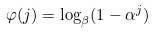Convert formula to latex. <formula><loc_0><loc_0><loc_500><loc_500>\varphi ( j ) = \log _ { \beta } ( 1 - \alpha ^ { j } )</formula> 